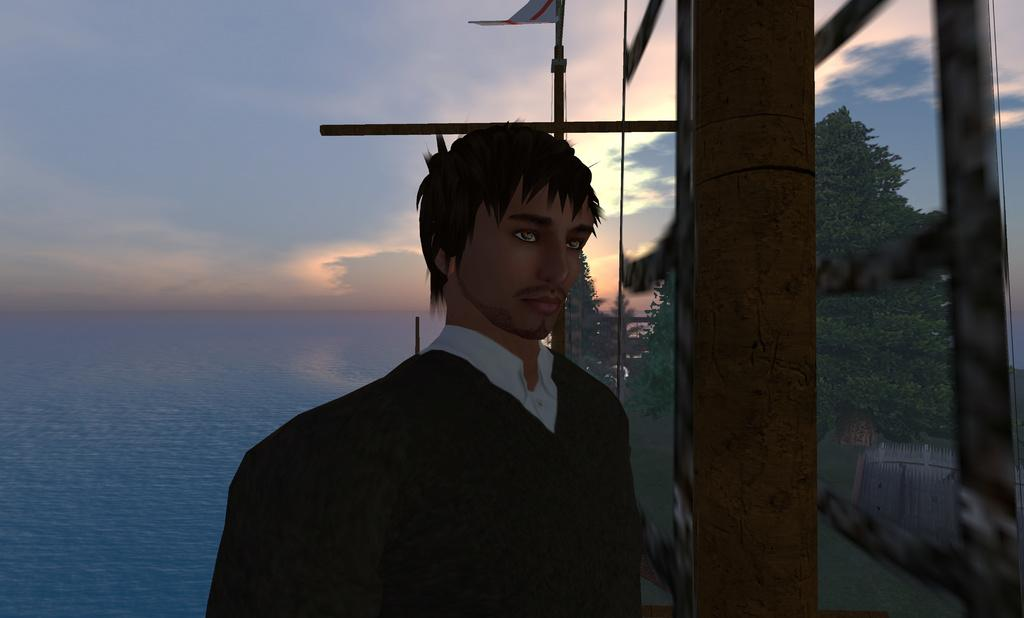What is the main subject of the graphic in the image? The facts provided do not specify the content of the graphic, so we cannot answer this question definitively. What is the person standing beside in the image? The person is standing beside a building. What can be seen in the background of the image? There is an ocean and a sky visible in the background of the image. What is the condition of the sky in the image? The sky has clouds in it. What type of arch can be seen in the image? There is no arch present in the image. Where is the mailbox located in the image? There is no mailbox present in the image. 